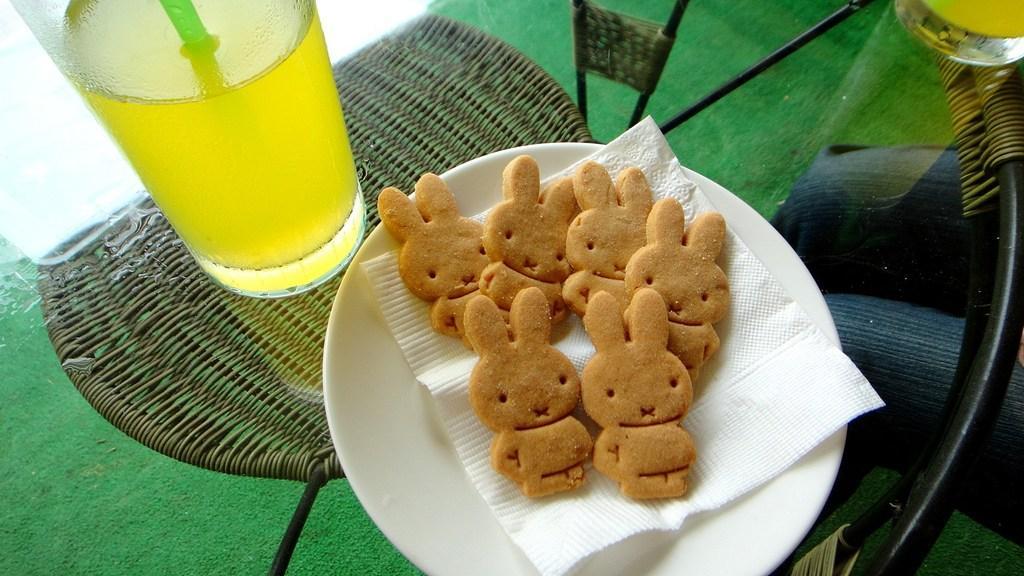Describe this image in one or two sentences. In this picture we can see a tissue paper and food in the plate, beside to the plate we can find few glasses on the table, and also we can see a person. 